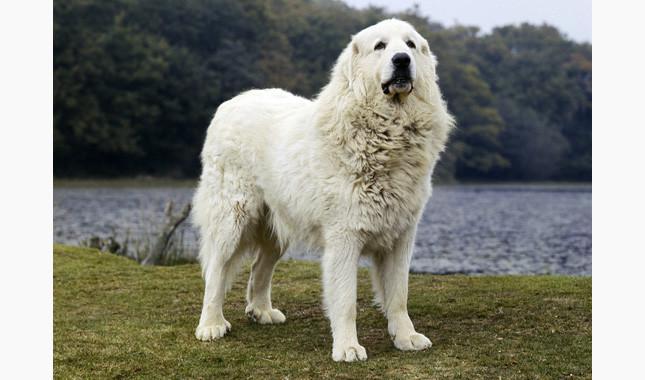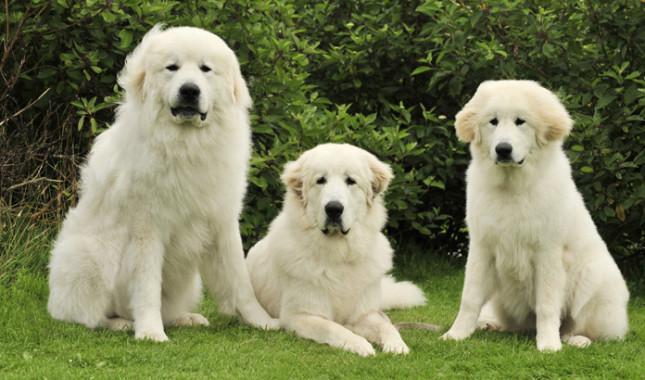The first image is the image on the left, the second image is the image on the right. For the images shown, is this caption "There are three dogs in total." true? Answer yes or no. No. The first image is the image on the left, the second image is the image on the right. For the images shown, is this caption "There is a total of four dogs." true? Answer yes or no. Yes. 